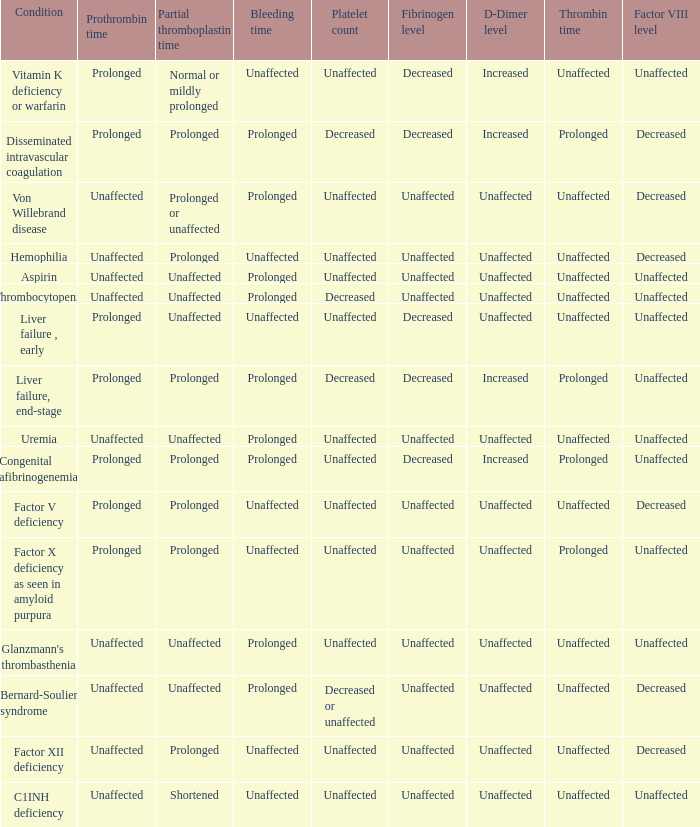Which Prothrombin time has a Platelet count of unaffected, and a Bleeding time of unaffected, and a Partial thromboplastin time of normal or mildly prolonged? Prolonged. Would you mind parsing the complete table? {'header': ['Condition', 'Prothrombin time', 'Partial thromboplastin time', 'Bleeding time', 'Platelet count', 'Fibrinogen level', 'D-Dimer level', 'Thrombin time', 'Factor VIII level'], 'rows': [['Vitamin K deficiency or warfarin', 'Prolonged', 'Normal or mildly prolonged', 'Unaffected', 'Unaffected', 'Decreased', 'Increased', 'Unaffected', 'Unaffected'], ['Disseminated intravascular coagulation', 'Prolonged', 'Prolonged', 'Prolonged', 'Decreased', 'Decreased', 'Increased', 'Prolonged', 'Decreased'], ['Von Willebrand disease', 'Unaffected', 'Prolonged or unaffected', 'Prolonged', 'Unaffected', 'Unaffected', 'Unaffected', 'Unaffected', 'Decreased'], ['Hemophilia', 'Unaffected', 'Prolonged', 'Unaffected', 'Unaffected', 'Unaffected', 'Unaffected', 'Unaffected', 'Decreased'], ['Aspirin', 'Unaffected', 'Unaffected', 'Prolonged', 'Unaffected', 'Unaffected', 'Unaffected', 'Unaffected', 'Unaffected'], ['Thrombocytopenia', 'Unaffected', 'Unaffected', 'Prolonged', 'Decreased', 'Unaffected', 'Unaffected', 'Unaffected', 'Unaffected'], ['Liver failure , early', 'Prolonged', 'Unaffected', 'Unaffected', 'Unaffected', 'Decreased', 'Unaffected', 'Unaffected', 'Unaffected'], ['Liver failure, end-stage', 'Prolonged', 'Prolonged', 'Prolonged', 'Decreased', 'Decreased', 'Increased', 'Prolonged', 'Unaffected'], ['Uremia', 'Unaffected', 'Unaffected', 'Prolonged', 'Unaffected', 'Unaffected', 'Unaffected', 'Unaffected', 'Unaffected'], ['Congenital afibrinogenemia', 'Prolonged', 'Prolonged', 'Prolonged', 'Unaffected', 'Decreased', 'Increased', 'Prolonged', 'Unaffected'], ['Factor V deficiency', 'Prolonged', 'Prolonged', 'Unaffected', 'Unaffected', 'Unaffected', 'Unaffected', 'Unaffected', 'Decreased'], ['Factor X deficiency as seen in amyloid purpura', 'Prolonged', 'Prolonged', 'Unaffected', 'Unaffected', 'Unaffected', 'Unaffected', 'Prolonged', 'Unaffected'], ["Glanzmann's thrombasthenia", 'Unaffected', 'Unaffected', 'Prolonged', 'Unaffected', 'Unaffected', 'Unaffected', 'Unaffected', 'Unaffected'], ['Bernard-Soulier syndrome', 'Unaffected', 'Unaffected', 'Prolonged', 'Decreased or unaffected', 'Unaffected', 'Unaffected', 'Unaffected', 'Decreased'], ['Factor XII deficiency', 'Unaffected', 'Prolonged', 'Unaffected', 'Unaffected', 'Unaffected', 'Unaffected', 'Unaffected', 'Decreased'], ['C1INH deficiency', 'Unaffected', 'Shortened', 'Unaffected', 'Unaffected', 'Unaffected', 'Unaffected', 'Unaffected', 'Unaffected']]} 